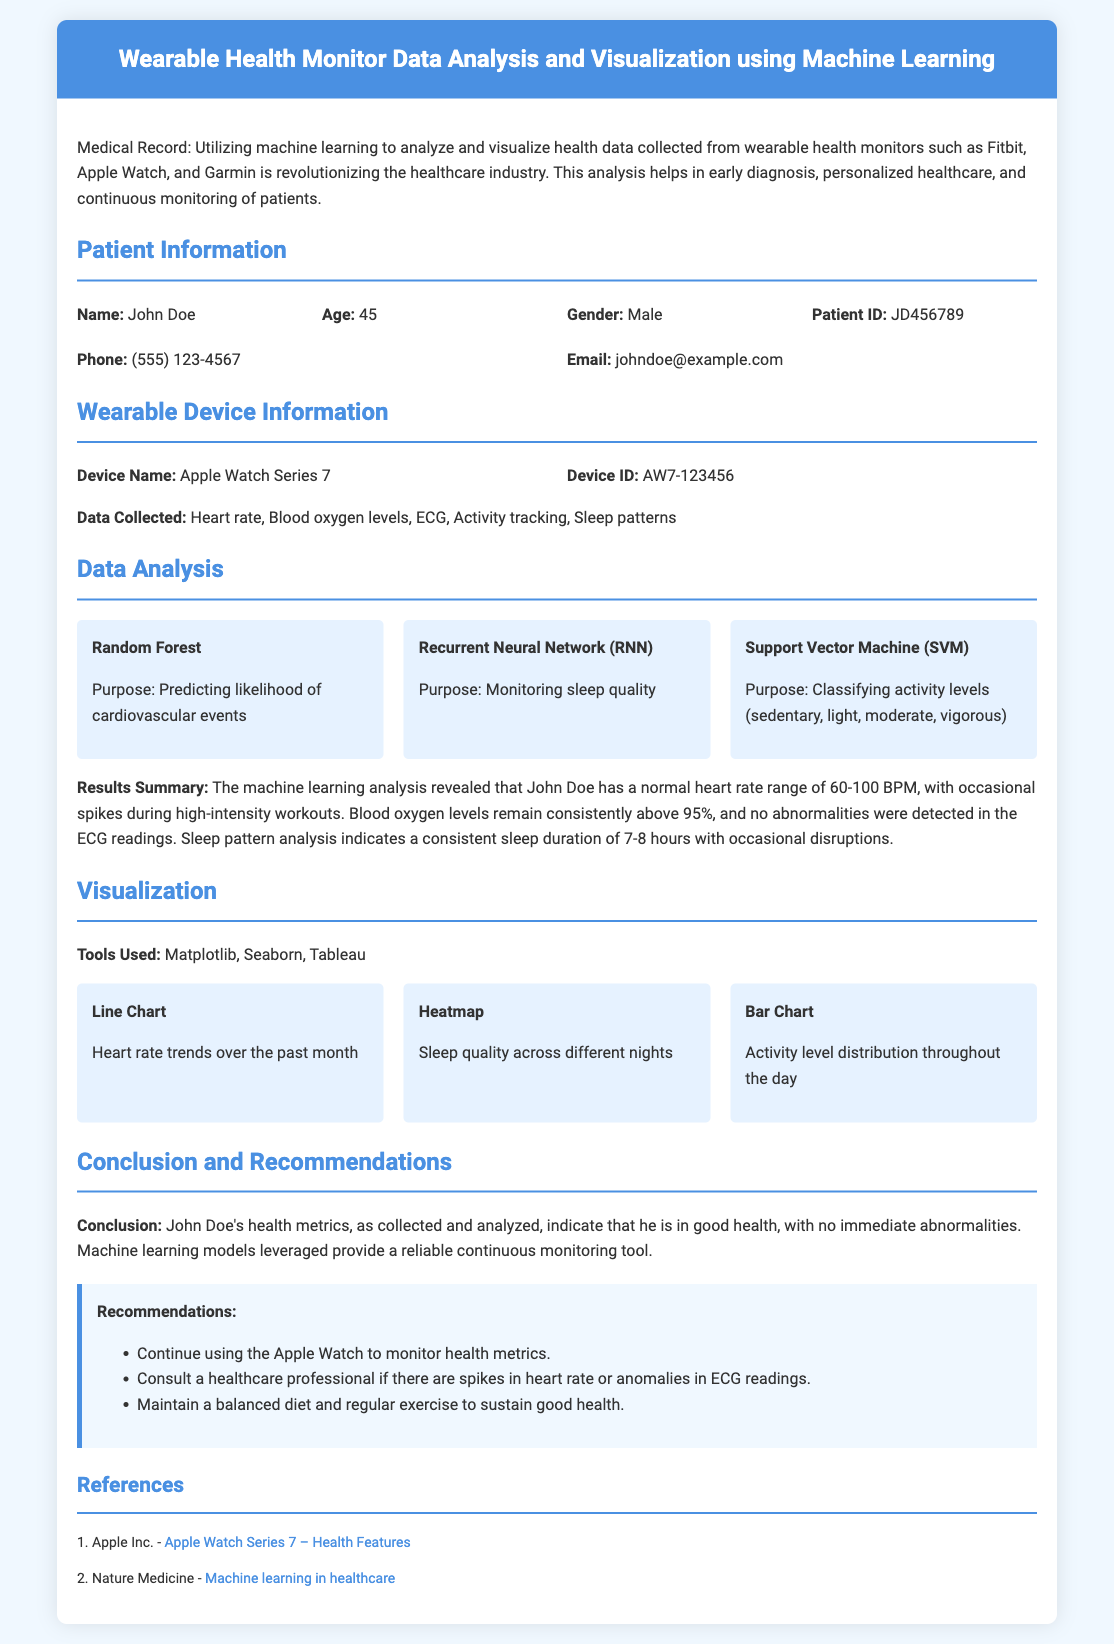What is the patient's name? The patient's name is specified in the patient information section of the document.
Answer: John Doe How old is the patient? The patient's age is provided in the patient information section.
Answer: 45 What wearable device is being used? The wearable device is mentioned in the device information section of the document.
Answer: Apple Watch Series 7 What is the device ID? The device ID is listed in the device information section.
Answer: AW7-123456 What data is collected from the wearable device? The types of data collected from the wearable device are outlined in the document.
Answer: Heart rate, Blood oxygen levels, ECG, Activity tracking, Sleep patterns What is the purpose of the Random Forest model? The purpose of the Random Forest model is detailed in the data analysis section.
Answer: Predicting likelihood of cardiovascular events How many hours of sleep does John Doe consistently get? The sleep pattern analysis indicates sleep duration in the results summary.
Answer: 7-8 hours What recommendations are given regarding health monitoring? The recommendations section suggests follow-ups based on the analysis provided in the document.
Answer: Continue using the Apple Watch to monitor health metrics What is the conclusion about John Doe's health? The conclusion section summarizes the overall health status of the patient.
Answer: John Doe's health metrics indicate that he is in good health 